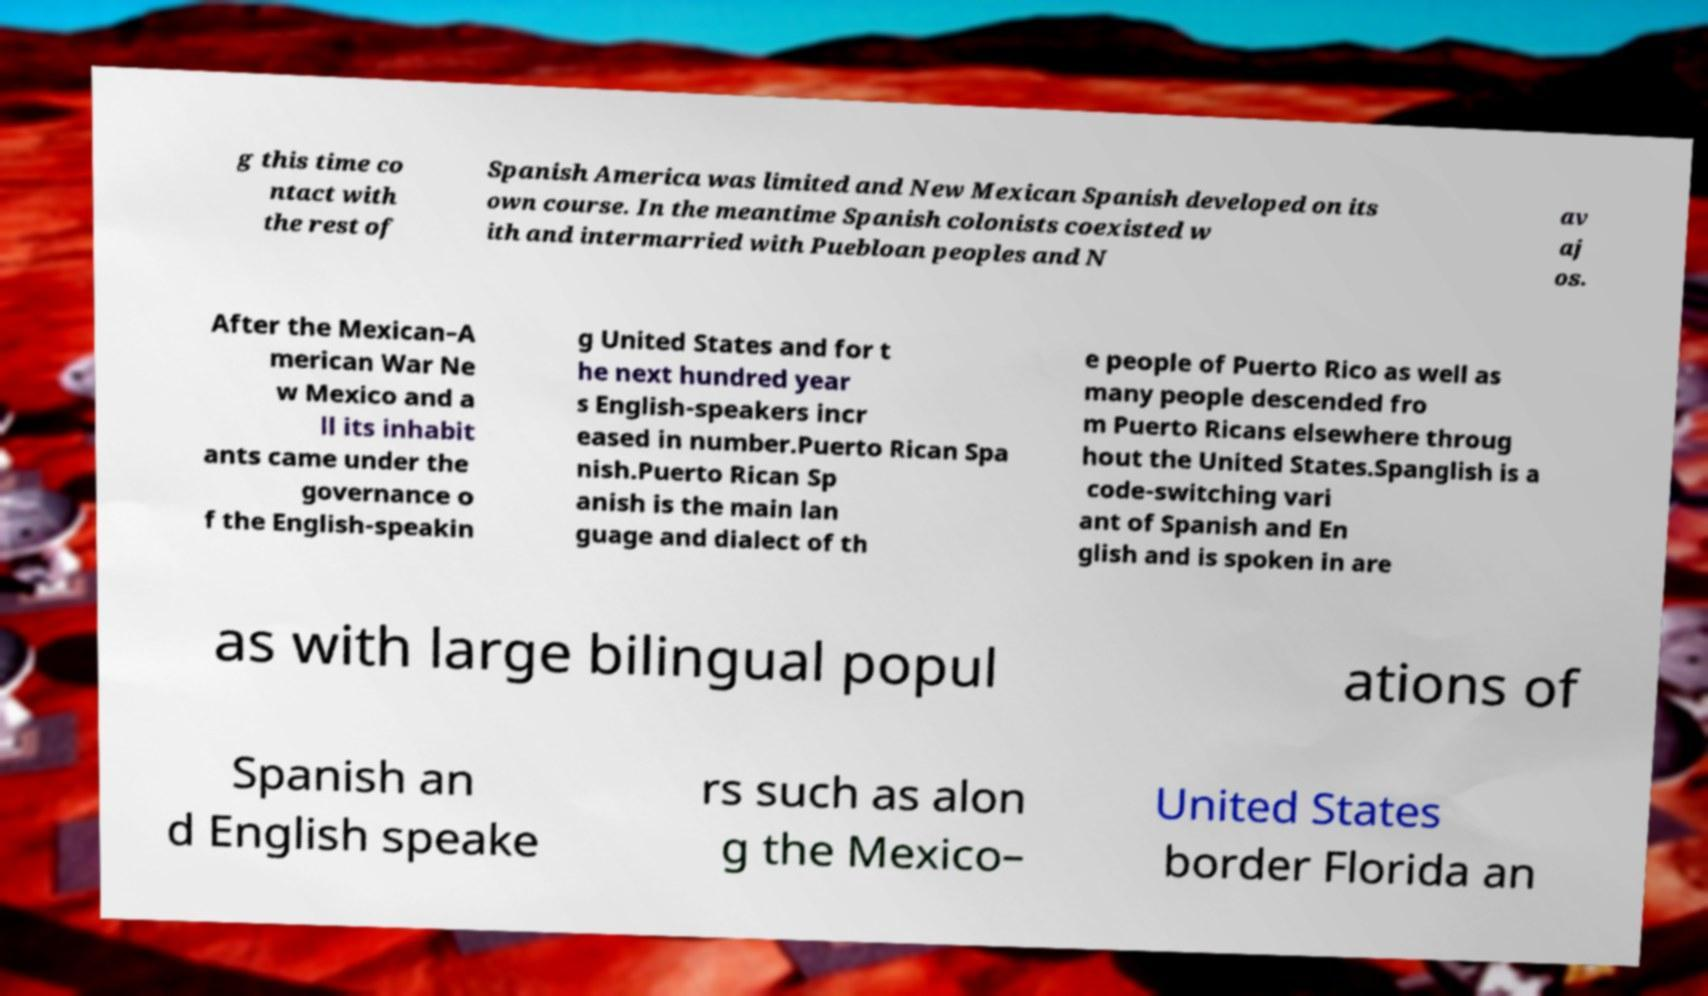I need the written content from this picture converted into text. Can you do that? g this time co ntact with the rest of Spanish America was limited and New Mexican Spanish developed on its own course. In the meantime Spanish colonists coexisted w ith and intermarried with Puebloan peoples and N av aj os. After the Mexican–A merican War Ne w Mexico and a ll its inhabit ants came under the governance o f the English-speakin g United States and for t he next hundred year s English-speakers incr eased in number.Puerto Rican Spa nish.Puerto Rican Sp anish is the main lan guage and dialect of th e people of Puerto Rico as well as many people descended fro m Puerto Ricans elsewhere throug hout the United States.Spanglish is a code-switching vari ant of Spanish and En glish and is spoken in are as with large bilingual popul ations of Spanish an d English speake rs such as alon g the Mexico– United States border Florida an 